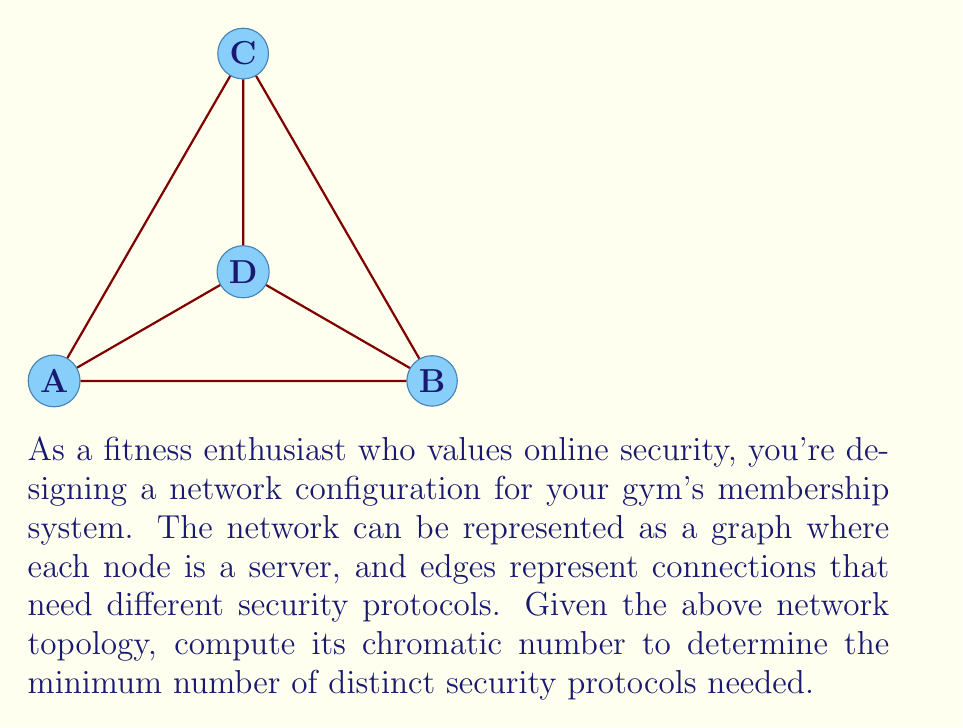Can you answer this question? To find the chromatic number of this network security configuration, we need to determine the minimum number of colors (representing distinct security protocols) needed to color the graph such that no adjacent nodes have the same color. Let's approach this step-by-step:

1) First, observe the structure of the graph:
   - It has 4 nodes (A, B, C, D)
   - It forms a complete graph K₄ (all nodes are connected to each other)

2) In a complete graph K_n, each node is adjacent to every other node. This means each node must have a unique color.

3) The chromatic number of a complete graph K_n is always n, where n is the number of nodes.

4) In this case, we have K₄, so the chromatic number is 4.

5) This means we need at least 4 distinct security protocols to ensure that no two adjacent servers (nodes) use the same protocol.

6) Coloring scheme (for visualization):
   - Node A: Color 1 (Protocol 1)
   - Node B: Color 2 (Protocol 2)
   - Node C: Color 3 (Protocol 3)
   - Node D: Color 4 (Protocol 4)

Therefore, the chromatic number of this network security configuration is 4, indicating that a minimum of 4 distinct security protocols are needed to secure the gym's membership system network.
Answer: $$4$$ 